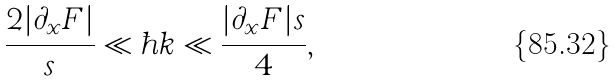Convert formula to latex. <formula><loc_0><loc_0><loc_500><loc_500>\frac { 2 | \partial _ { x } F | } { s } \ll \hbar { k } \ll \frac { | \partial _ { x } F | s } { 4 } ,</formula> 